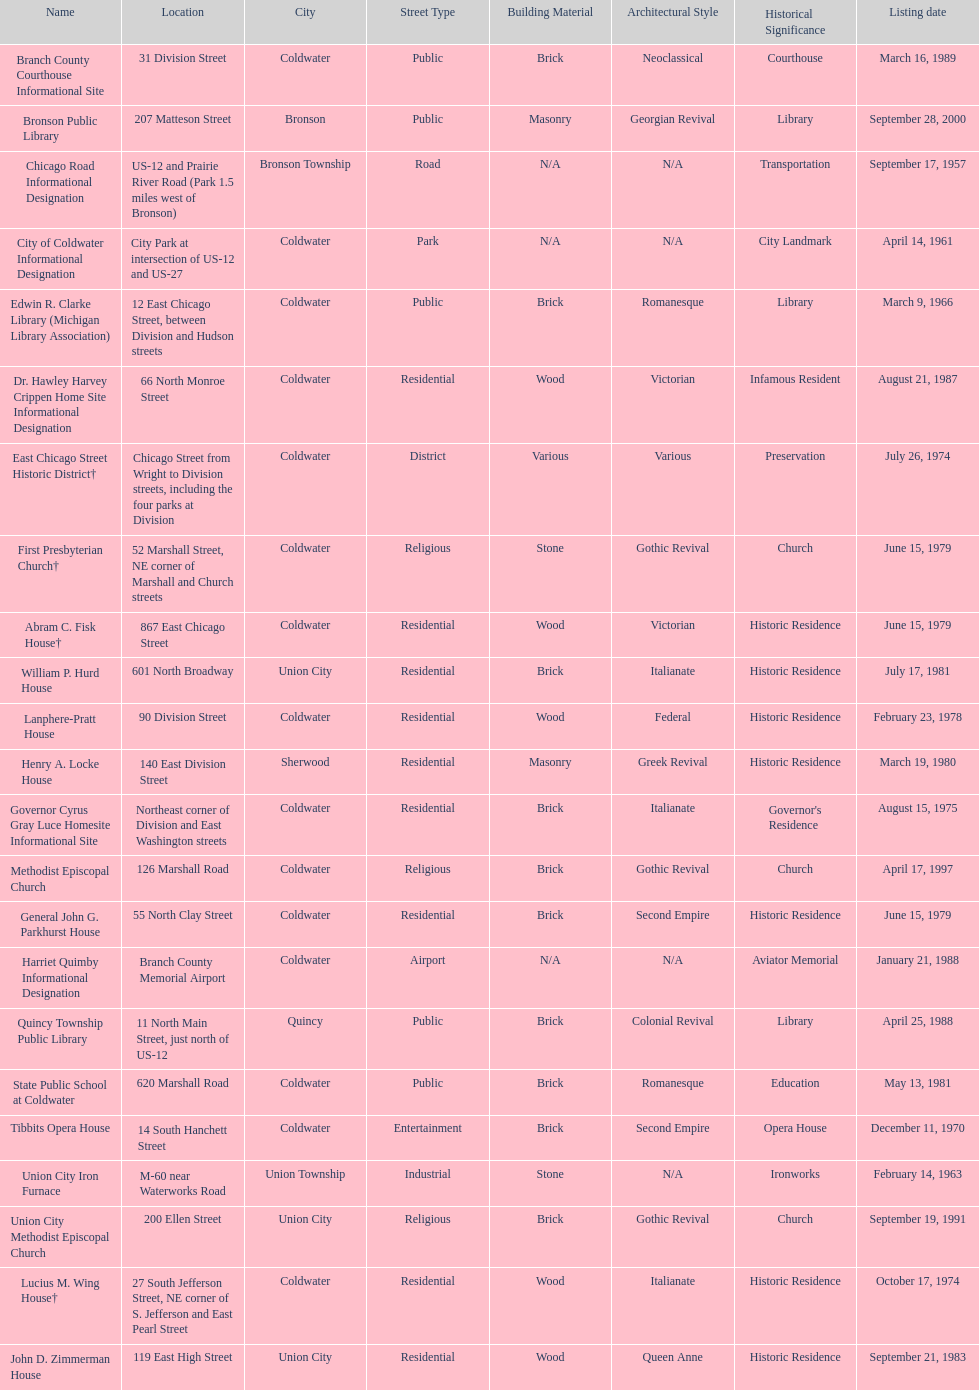How many historic sites were listed before 1965? 3. 